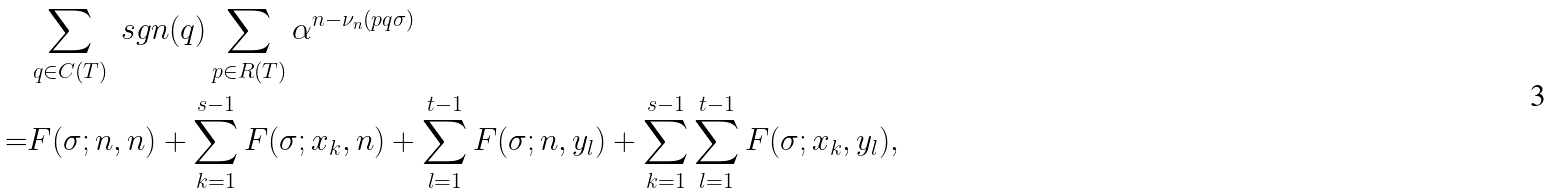Convert formula to latex. <formula><loc_0><loc_0><loc_500><loc_500>& \sum _ { q \in C ( T ) } \ s g n ( q ) \sum _ { p \in R ( T ) } \alpha ^ { n - \nu _ { n } ( p q \sigma ) } \\ = & F ( \sigma ; n , n ) + \sum _ { k = 1 } ^ { s - 1 } F ( \sigma ; x _ { k } , n ) + \sum _ { l = 1 } ^ { t - 1 } F ( \sigma ; n , y _ { l } ) + \sum _ { k = 1 } ^ { s - 1 } \sum _ { l = 1 } ^ { t - 1 } F ( \sigma ; x _ { k } , y _ { l } ) ,</formula> 